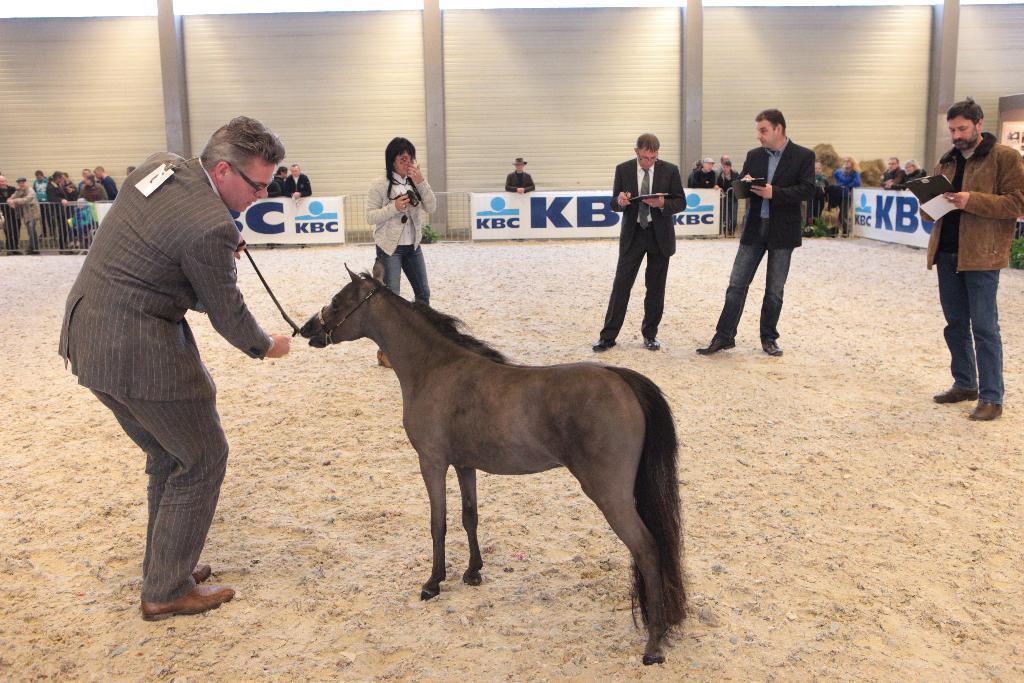Please provide a concise description of this image. As we can see in the image there are few people standing, a horse and a banner. 